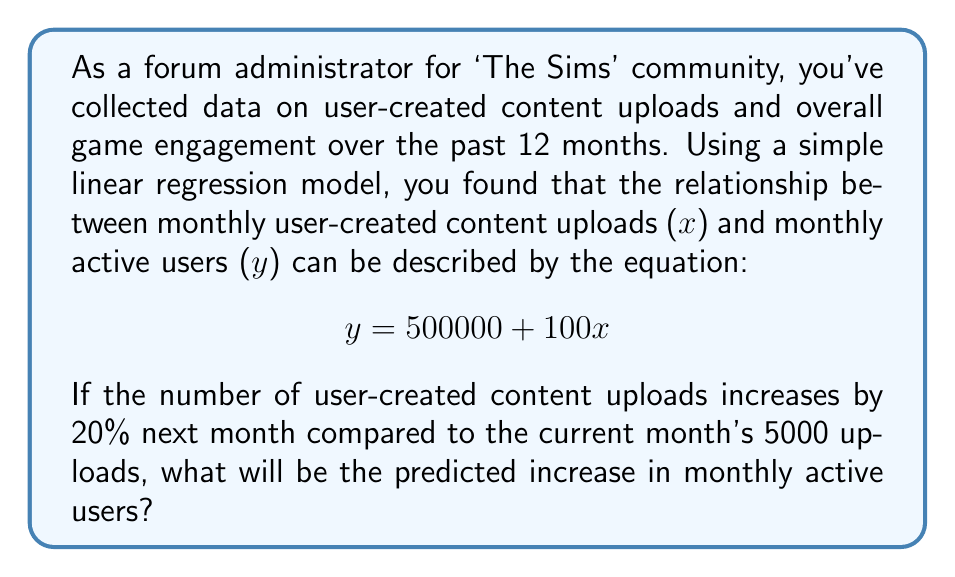Show me your answer to this math problem. Let's approach this step-by-step:

1) First, we need to calculate the new number of user-created content uploads after a 20% increase:
   Current uploads = 5000
   Increase = 20% = 0.2
   New uploads = 5000 * (1 + 0.2) = 5000 * 1.2 = 6000

2) Now, we can use the linear regression equation to predict the number of monthly active users for both the current and new upload numbers:

   Current: $y_1 = 500000 + 100(5000) = 1000000$
   New: $y_2 = 500000 + 100(6000) = 1100000$

3) To find the increase in monthly active users, we subtract the current from the new:

   $\text{Increase} = y_2 - y_1 = 1100000 - 1000000 = 100000$

Therefore, the predicted increase in monthly active users is 100,000.
Answer: 100,000 